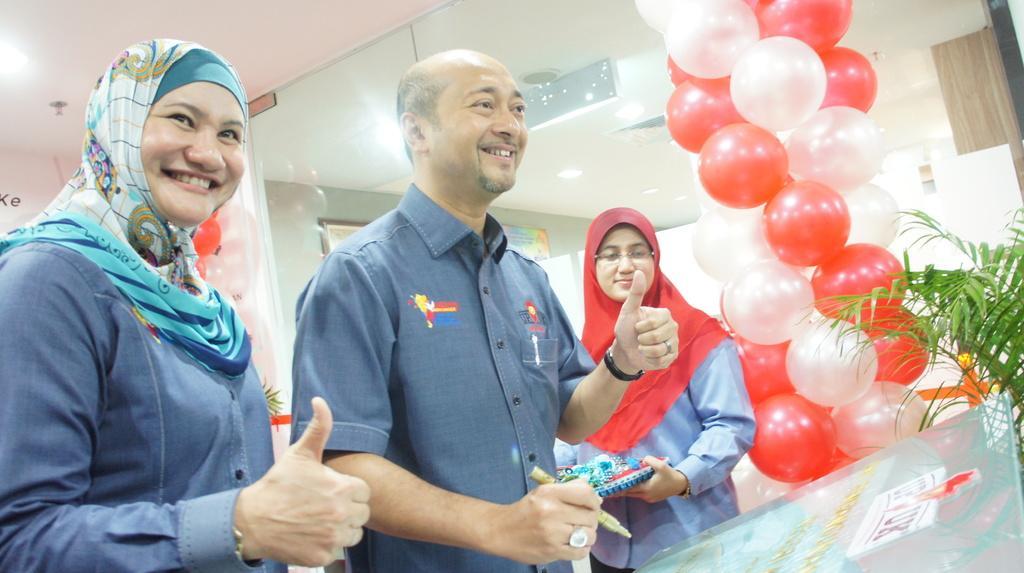Describe this image in one or two sentences. In this image there are three people standing with a smile on their face, one of them is holding an object in her hand and the other one is holding a pen in his hand, beside them there are balloons, in front of them there is a glass board with some text. In the background there is a glass door. 